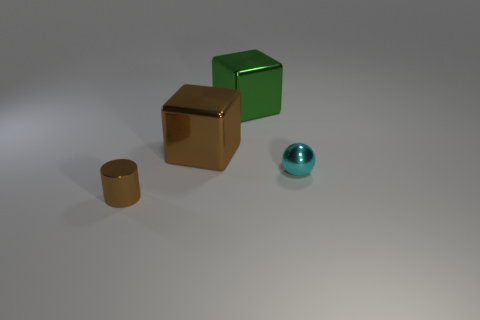Add 3 objects. How many objects exist? 7 Subtract all spheres. How many objects are left? 3 Add 2 tiny shiny spheres. How many tiny shiny spheres are left? 3 Add 4 cyan metal spheres. How many cyan metal spheres exist? 5 Subtract 0 gray spheres. How many objects are left? 4 Subtract all large blue metallic objects. Subtract all cyan spheres. How many objects are left? 3 